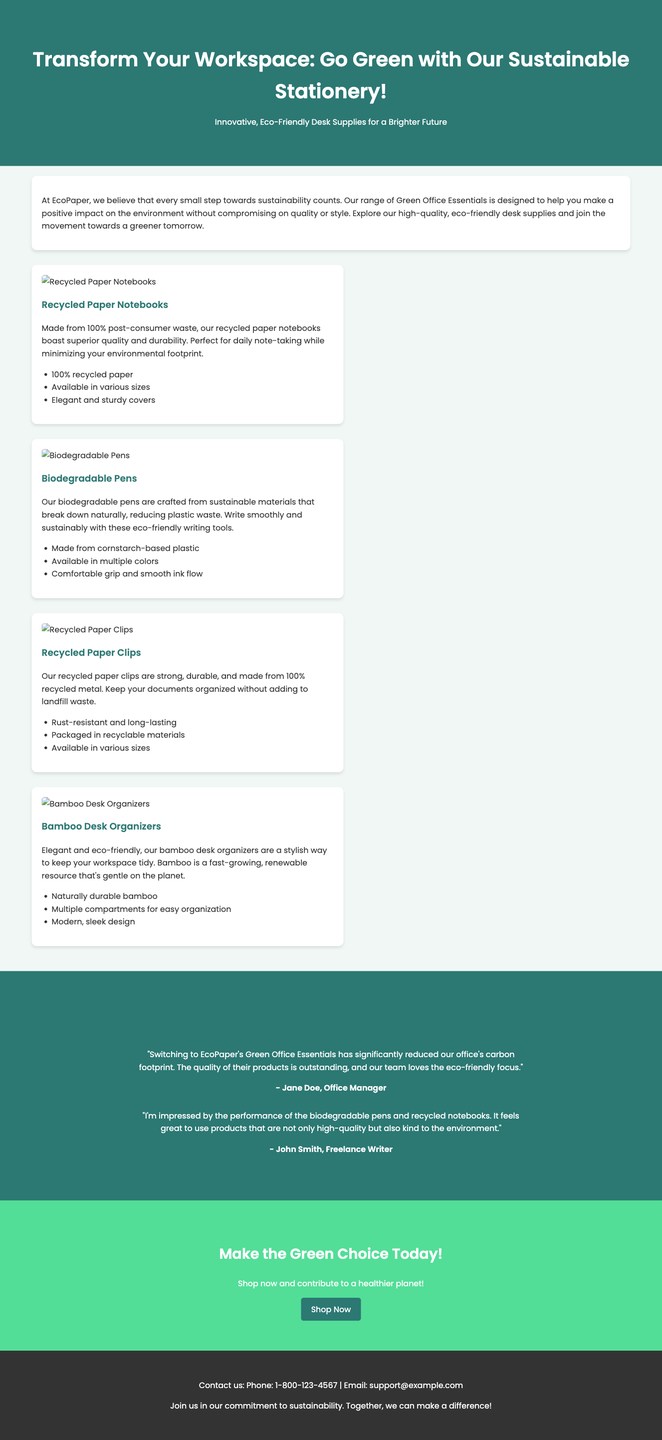What is the name of the company? The name of the company promoting the products in the advertisement is provided at the beginning of the document.
Answer: EcoPaper What is one feature of the recycled paper notebooks? The features of the recycled paper notebooks are mentioned in the product section, focusing on its composition.
Answer: 100% recycled paper What materials are the biodegradable pens made from? The materials used for the biodegradable pens are summarized in the product description, indicating its composition.
Answer: Cornstarch-based plastic How many testimonials are presented in the advertisement? The number of testimonials can be counted in the testimonials section of the document.
Answer: 2 What is the primary color of the header background? The background color of the header is described in the style section and can be identified from the advertisement's design.
Answer: #2c7873 What product is designed to keep objects organized on a desk? The products listed in the advertisement detail their purposes, including one specifically for organization.
Answer: Bamboo Desk Organizers What is the main call to action in the advertisement? The call to action is emphasized in the last section, urging customers to take specific action.
Answer: Shop Now What kind of paper clips are featured in the advertisement? The product section specifies the type of paper clips highlighted in the advertisement.
Answer: Recycled Paper Clips What testimonial mentions the reduction of carbon footprint? The content of one testimonial explicitly mentions the impact on carbon footprint.
Answer: Jane Doe, Office Manager 